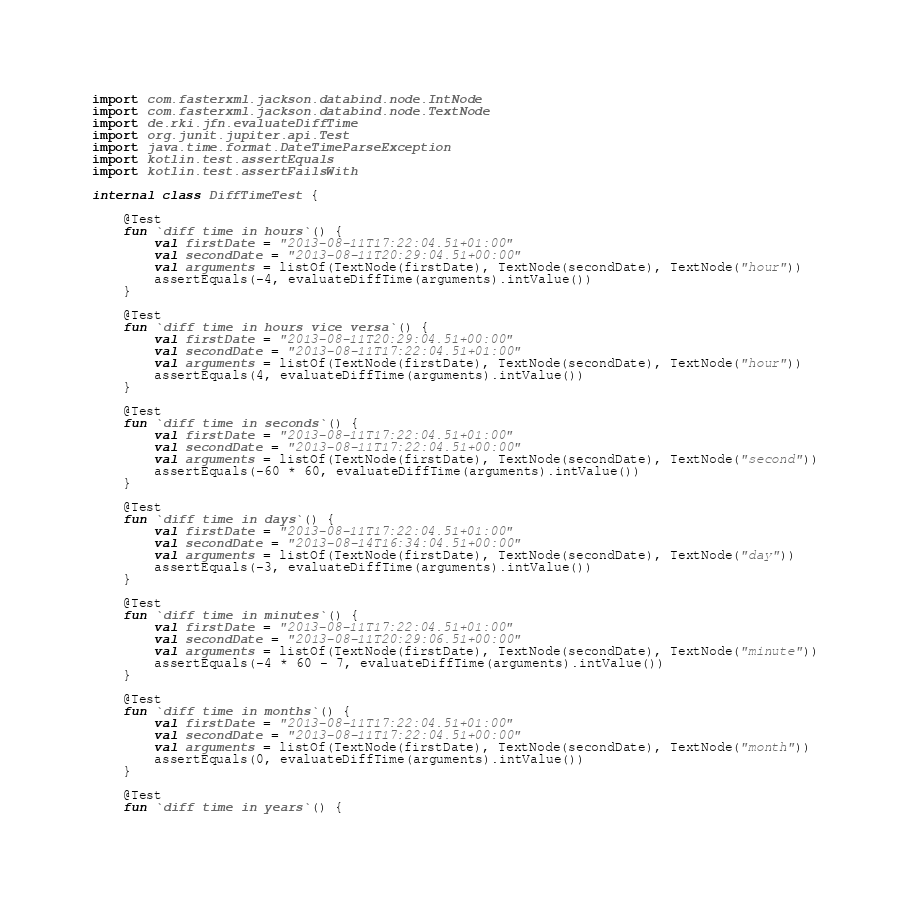<code> <loc_0><loc_0><loc_500><loc_500><_Kotlin_>import com.fasterxml.jackson.databind.node.IntNode
import com.fasterxml.jackson.databind.node.TextNode
import de.rki.jfn.evaluateDiffTime
import org.junit.jupiter.api.Test
import java.time.format.DateTimeParseException
import kotlin.test.assertEquals
import kotlin.test.assertFailsWith

internal class DiffTimeTest {

    @Test
    fun `diff time in hours`() {
        val firstDate = "2013-08-11T17:22:04.51+01:00"
        val secondDate = "2013-08-11T20:29:04.51+00:00"
        val arguments = listOf(TextNode(firstDate), TextNode(secondDate), TextNode("hour"))
        assertEquals(-4, evaluateDiffTime(arguments).intValue())
    }

    @Test
    fun `diff time in hours vice versa`() {
        val firstDate = "2013-08-11T20:29:04.51+00:00"
        val secondDate = "2013-08-11T17:22:04.51+01:00"
        val arguments = listOf(TextNode(firstDate), TextNode(secondDate), TextNode("hour"))
        assertEquals(4, evaluateDiffTime(arguments).intValue())
    }

    @Test
    fun `diff time in seconds`() {
        val firstDate = "2013-08-11T17:22:04.51+01:00"
        val secondDate = "2013-08-11T17:22:04.51+00:00"
        val arguments = listOf(TextNode(firstDate), TextNode(secondDate), TextNode("second"))
        assertEquals(-60 * 60, evaluateDiffTime(arguments).intValue())
    }

    @Test
    fun `diff time in days`() {
        val firstDate = "2013-08-11T17:22:04.51+01:00"
        val secondDate = "2013-08-14T16:34:04.51+00:00"
        val arguments = listOf(TextNode(firstDate), TextNode(secondDate), TextNode("day"))
        assertEquals(-3, evaluateDiffTime(arguments).intValue())
    }

    @Test
    fun `diff time in minutes`() {
        val firstDate = "2013-08-11T17:22:04.51+01:00"
        val secondDate = "2013-08-11T20:29:06.51+00:00"
        val arguments = listOf(TextNode(firstDate), TextNode(secondDate), TextNode("minute"))
        assertEquals(-4 * 60 - 7, evaluateDiffTime(arguments).intValue())
    }

    @Test
    fun `diff time in months`() {
        val firstDate = "2013-08-11T17:22:04.51+01:00"
        val secondDate = "2013-08-11T17:22:04.51+00:00"
        val arguments = listOf(TextNode(firstDate), TextNode(secondDate), TextNode("month"))
        assertEquals(0, evaluateDiffTime(arguments).intValue())
    }

    @Test
    fun `diff time in years`() {</code> 